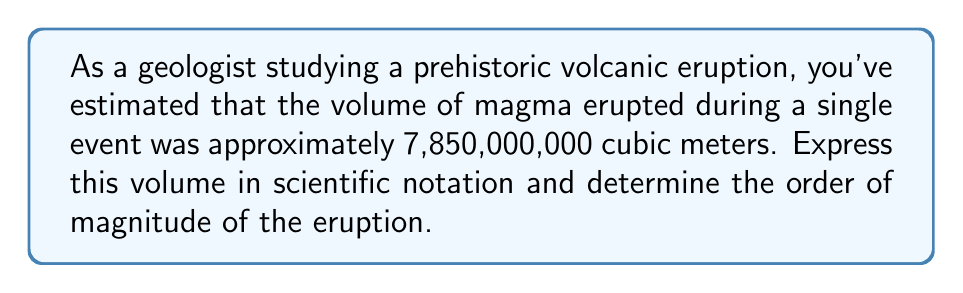Solve this math problem. To solve this problem, we need to follow these steps:

1) Convert the number to scientific notation:
   $7,850,000,000 = 7.85 \times 10^9$ cubic meters

   To arrive at this:
   - We move the decimal point 9 places to the left
   - This gives us 7.85 as the coefficient
   - The exponent becomes 9 because we moved the decimal 9 places

2) Determine the order of magnitude:
   The order of magnitude is the power of 10 in the scientific notation.
   In this case, it's 9.

   In geological terms:
   - $10^6 - 10^9$ cubic meters: Large eruption
   - $10^9 - 10^{11}$ cubic meters: Very large eruption
   - $>10^{11}$ cubic meters: Super eruption

   Our eruption falls into the "Very large eruption" category.

3) Interpretation:
   This volume suggests a significant geological event. For context, the 1980 eruption of Mount St. Helens in the United States ejected about $2.79 \times 10^9$ cubic meters of material, while the 1815 eruption of Mount Tambora in Indonesia, one of the largest in recorded history, ejected about $1.6 \times 10^{11}$ cubic meters.
Answer: Volume in scientific notation: $7.85 \times 10^9$ cubic meters
Order of magnitude: 9
Classification: Very large eruption 